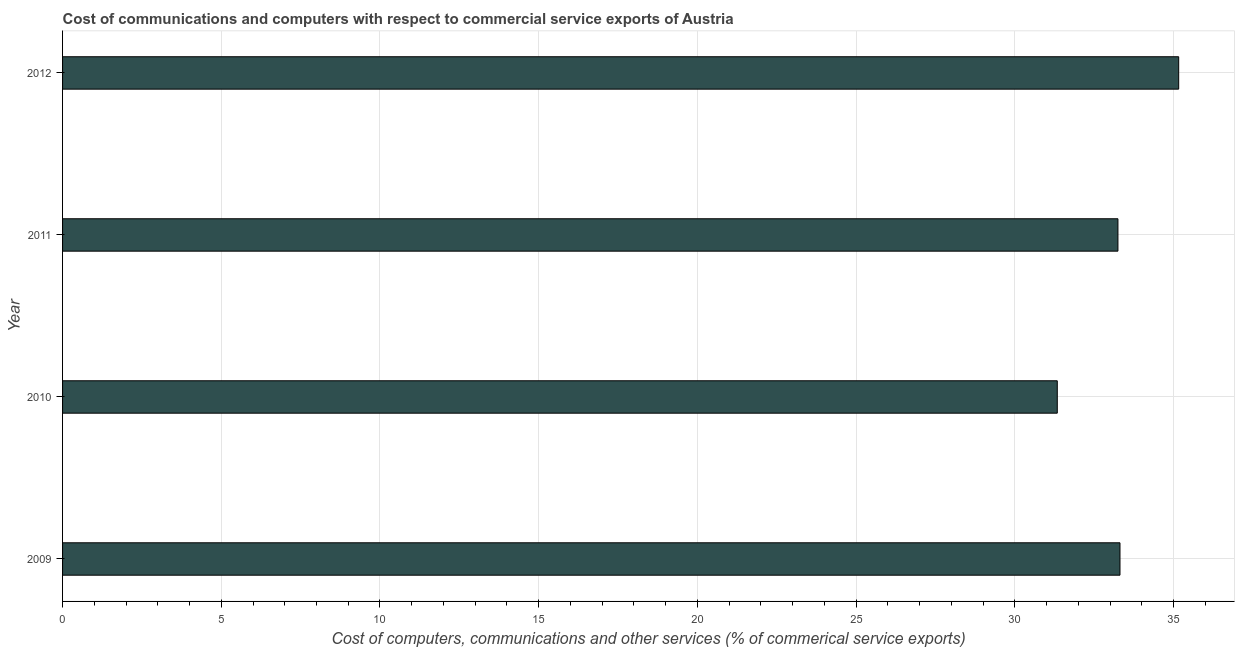Does the graph contain any zero values?
Your answer should be very brief. No. Does the graph contain grids?
Make the answer very short. Yes. What is the title of the graph?
Provide a succinct answer. Cost of communications and computers with respect to commercial service exports of Austria. What is the label or title of the X-axis?
Ensure brevity in your answer.  Cost of computers, communications and other services (% of commerical service exports). What is the label or title of the Y-axis?
Offer a very short reply. Year. What is the  computer and other services in 2009?
Give a very brief answer. 33.31. Across all years, what is the maximum cost of communications?
Give a very brief answer. 35.16. Across all years, what is the minimum cost of communications?
Give a very brief answer. 31.34. In which year was the cost of communications minimum?
Your answer should be very brief. 2010. What is the sum of the cost of communications?
Keep it short and to the point. 133.07. What is the difference between the  computer and other services in 2011 and 2012?
Make the answer very short. -1.91. What is the average  computer and other services per year?
Offer a very short reply. 33.27. What is the median  computer and other services?
Make the answer very short. 33.28. Do a majority of the years between 2011 and 2012 (inclusive) have  computer and other services greater than 21 %?
Your answer should be compact. Yes. Is the difference between the cost of communications in 2010 and 2011 greater than the difference between any two years?
Keep it short and to the point. No. What is the difference between the highest and the second highest cost of communications?
Your response must be concise. 1.85. Is the sum of the cost of communications in 2009 and 2011 greater than the maximum cost of communications across all years?
Your answer should be compact. Yes. What is the difference between the highest and the lowest cost of communications?
Give a very brief answer. 3.83. Are all the bars in the graph horizontal?
Your response must be concise. Yes. Are the values on the major ticks of X-axis written in scientific E-notation?
Ensure brevity in your answer.  No. What is the Cost of computers, communications and other services (% of commerical service exports) of 2009?
Offer a terse response. 33.31. What is the Cost of computers, communications and other services (% of commerical service exports) of 2010?
Your answer should be very brief. 31.34. What is the Cost of computers, communications and other services (% of commerical service exports) of 2011?
Offer a terse response. 33.25. What is the Cost of computers, communications and other services (% of commerical service exports) of 2012?
Make the answer very short. 35.16. What is the difference between the Cost of computers, communications and other services (% of commerical service exports) in 2009 and 2010?
Your answer should be very brief. 1.98. What is the difference between the Cost of computers, communications and other services (% of commerical service exports) in 2009 and 2011?
Offer a terse response. 0.06. What is the difference between the Cost of computers, communications and other services (% of commerical service exports) in 2009 and 2012?
Offer a very short reply. -1.85. What is the difference between the Cost of computers, communications and other services (% of commerical service exports) in 2010 and 2011?
Provide a short and direct response. -1.91. What is the difference between the Cost of computers, communications and other services (% of commerical service exports) in 2010 and 2012?
Ensure brevity in your answer.  -3.83. What is the difference between the Cost of computers, communications and other services (% of commerical service exports) in 2011 and 2012?
Your response must be concise. -1.91. What is the ratio of the Cost of computers, communications and other services (% of commerical service exports) in 2009 to that in 2010?
Ensure brevity in your answer.  1.06. What is the ratio of the Cost of computers, communications and other services (% of commerical service exports) in 2009 to that in 2012?
Your answer should be very brief. 0.95. What is the ratio of the Cost of computers, communications and other services (% of commerical service exports) in 2010 to that in 2011?
Offer a terse response. 0.94. What is the ratio of the Cost of computers, communications and other services (% of commerical service exports) in 2010 to that in 2012?
Your answer should be compact. 0.89. What is the ratio of the Cost of computers, communications and other services (% of commerical service exports) in 2011 to that in 2012?
Provide a succinct answer. 0.95. 